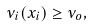<formula> <loc_0><loc_0><loc_500><loc_500>\nu _ { i } ( x _ { i } ) \geq \nu _ { o } ,</formula> 